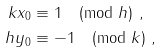<formula> <loc_0><loc_0><loc_500><loc_500>k x _ { 0 } & \equiv 1 \pmod { h } \ , \\ h y _ { 0 } & \equiv - 1 \pmod { k } \ ,</formula> 